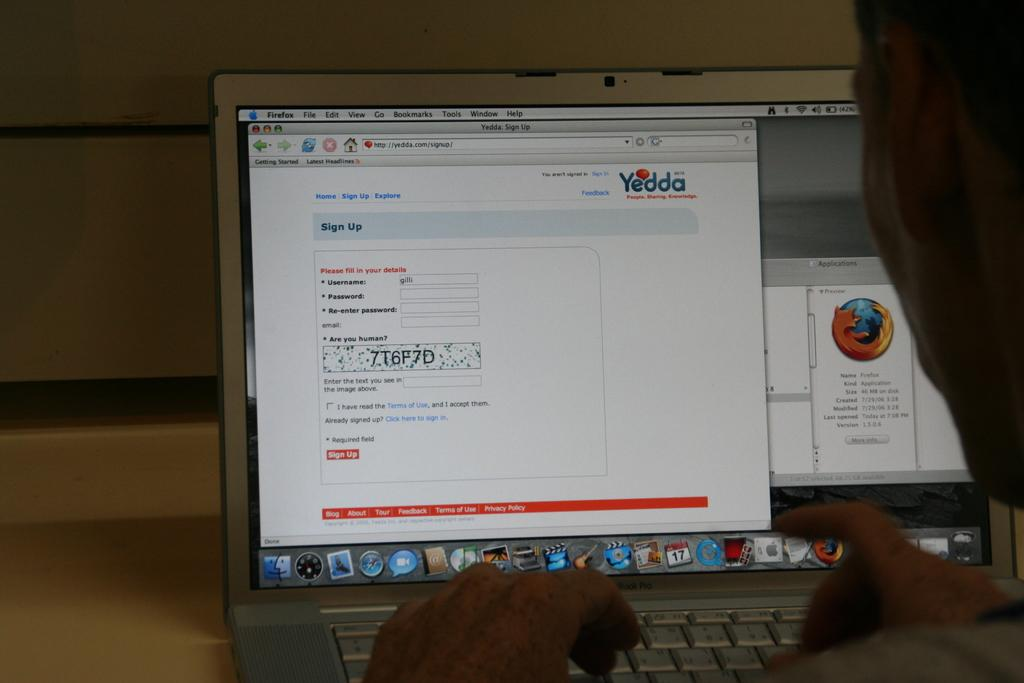Provide a one-sentence caption for the provided image. A person has just typed their username into the box. 